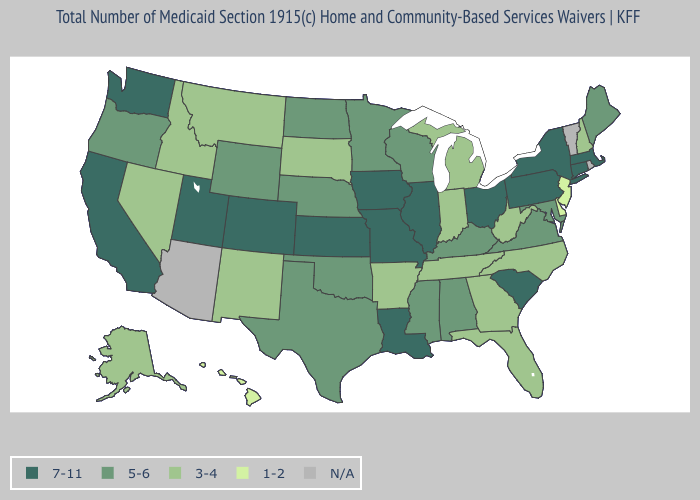Does North Carolina have the highest value in the USA?
Short answer required. No. Which states have the lowest value in the MidWest?
Concise answer only. Indiana, Michigan, South Dakota. What is the value of Massachusetts?
Short answer required. 7-11. Name the states that have a value in the range 3-4?
Keep it brief. Alaska, Arkansas, Florida, Georgia, Idaho, Indiana, Michigan, Montana, Nevada, New Hampshire, New Mexico, North Carolina, South Dakota, Tennessee, West Virginia. Does the map have missing data?
Keep it brief. Yes. What is the highest value in the Northeast ?
Write a very short answer. 7-11. Name the states that have a value in the range 5-6?
Write a very short answer. Alabama, Kentucky, Maine, Maryland, Minnesota, Mississippi, Nebraska, North Dakota, Oklahoma, Oregon, Texas, Virginia, Wisconsin, Wyoming. Name the states that have a value in the range 7-11?
Be succinct. California, Colorado, Connecticut, Illinois, Iowa, Kansas, Louisiana, Massachusetts, Missouri, New York, Ohio, Pennsylvania, South Carolina, Utah, Washington. Name the states that have a value in the range 3-4?
Answer briefly. Alaska, Arkansas, Florida, Georgia, Idaho, Indiana, Michigan, Montana, Nevada, New Hampshire, New Mexico, North Carolina, South Dakota, Tennessee, West Virginia. Name the states that have a value in the range N/A?
Give a very brief answer. Arizona, Rhode Island, Vermont. Does South Carolina have the lowest value in the South?
Write a very short answer. No. What is the value of South Carolina?
Concise answer only. 7-11. What is the value of Florida?
Answer briefly. 3-4. Name the states that have a value in the range 3-4?
Quick response, please. Alaska, Arkansas, Florida, Georgia, Idaho, Indiana, Michigan, Montana, Nevada, New Hampshire, New Mexico, North Carolina, South Dakota, Tennessee, West Virginia. 